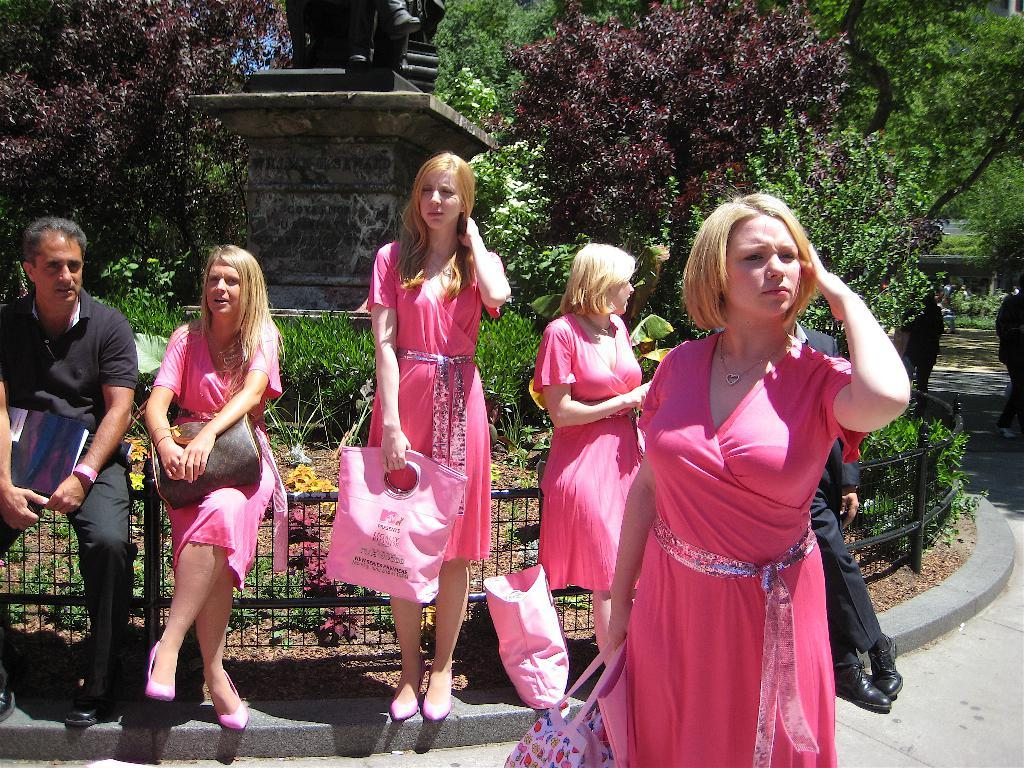How many people are in the image? There are people in the image, but the exact number is not specified. What are some women wearing in the image? Some women are wearing pink dresses in the image. What are two people holding in the image? Two people are holding bags in the image. What is a man holding in the image? A man is holding a book in the image. What can be seen in the background of the image? In the background of the image, there are statues, plants, a fence, and trees. What type of grape is being used as a prop in the image? There is no grape present in the image. How do the people in the image react to the sudden change in weather? The facts provided do not mention any weather conditions or reactions from the people in the image. 